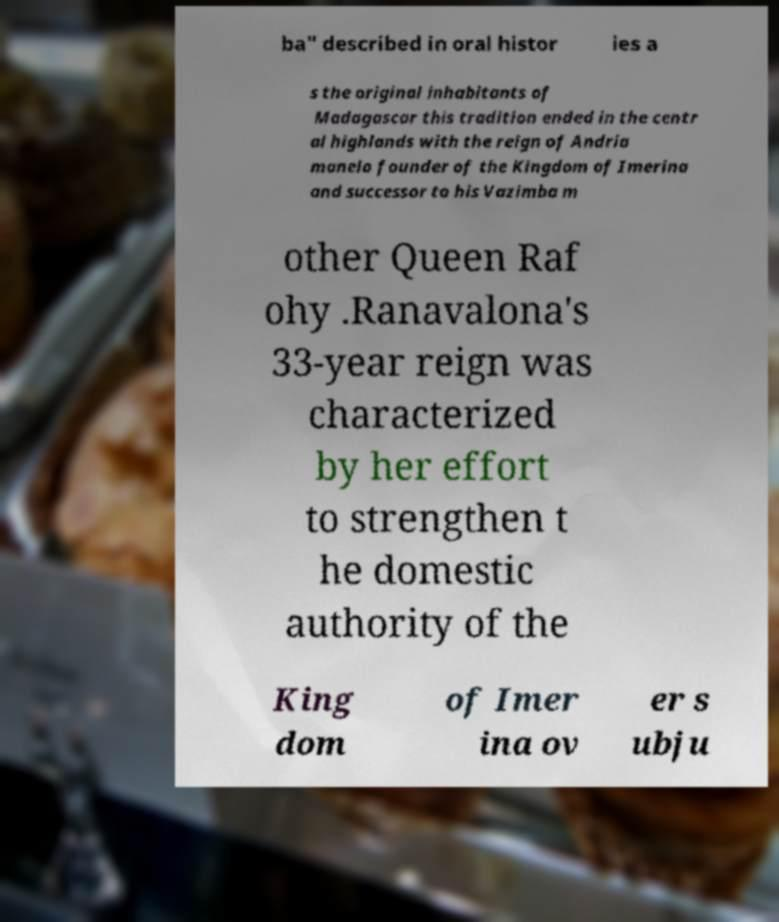Please read and relay the text visible in this image. What does it say? ba" described in oral histor ies a s the original inhabitants of Madagascar this tradition ended in the centr al highlands with the reign of Andria manelo founder of the Kingdom of Imerina and successor to his Vazimba m other Queen Raf ohy .Ranavalona's 33-year reign was characterized by her effort to strengthen t he domestic authority of the King dom of Imer ina ov er s ubju 